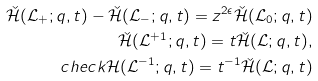Convert formula to latex. <formula><loc_0><loc_0><loc_500><loc_500>\check { \mathcal { H } } ( \mathcal { L } _ { + } ; q , t ) - \check { \mathcal { H } } ( \mathcal { L } _ { - } ; q , t ) = z ^ { 2 \epsilon } \check { \mathcal { H } } ( \mathcal { L } _ { 0 } ; q , t ) \\ \check { \mathcal { H } } ( \mathcal { L } ^ { + 1 } ; q , t ) = t \check { \mathcal { H } } ( \mathcal { L } ; q , t ) , \\ c h e c k { \mathcal { H } } ( \mathcal { L } ^ { - 1 } ; q , t ) = t ^ { - 1 } \check { \mathcal { H } } ( \mathcal { L } ; q , t )</formula> 